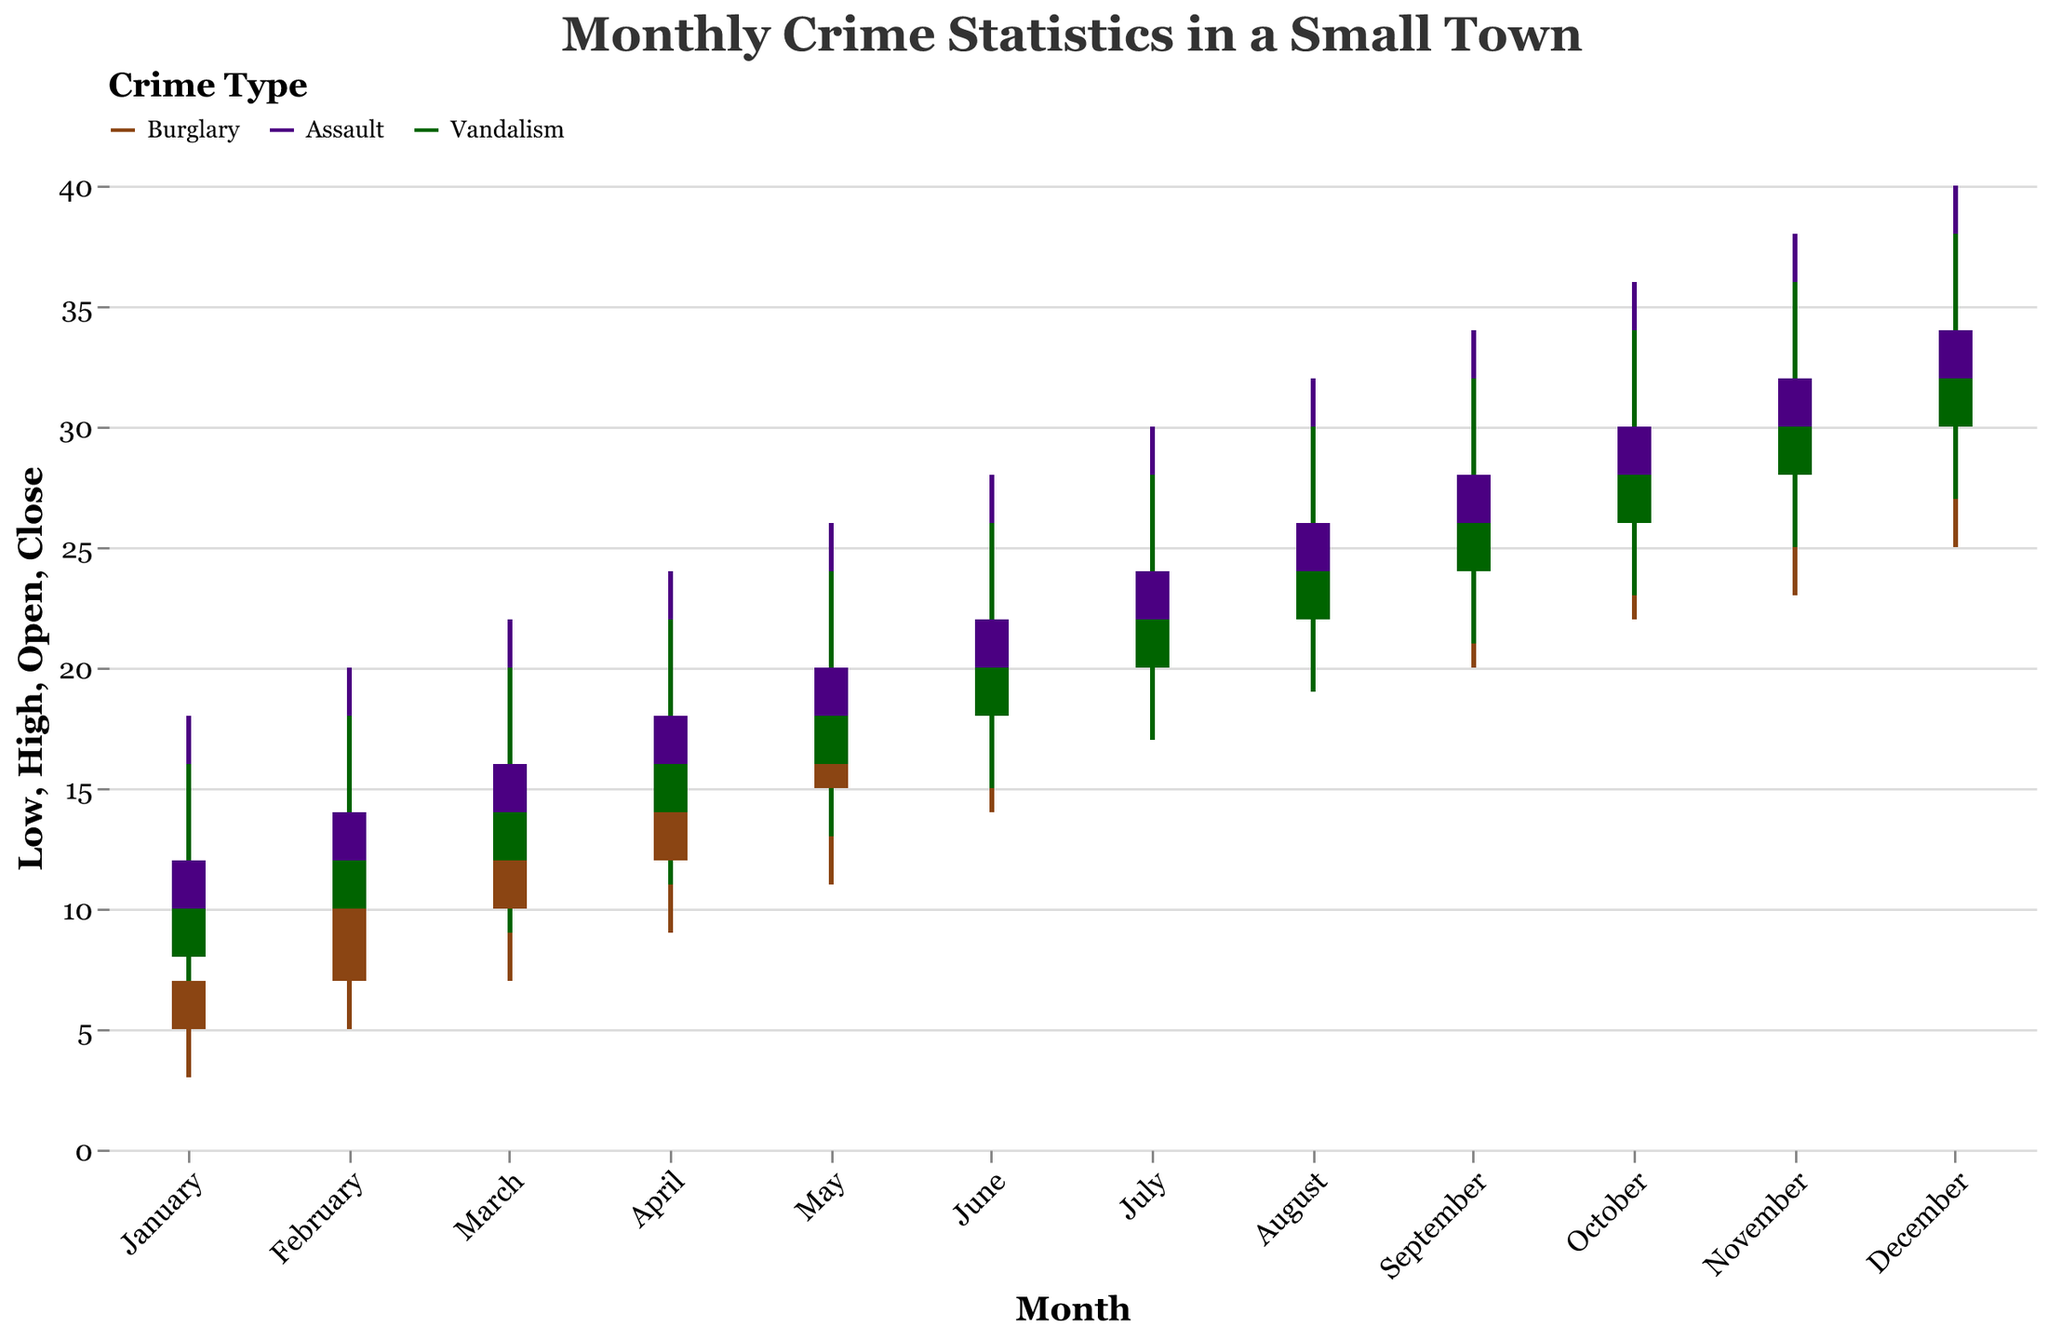What is the title of the candlestick chart? The title of the chart can be found at the top of the figure. It reads "Monthly Crime Statistics in a Small Town," which summarizes the content and focus of the visual representation.
Answer: Monthly Crime Statistics in a Small Town Which month recorded the highest number of burglary incidents? Referring to the candlestick bars for burglary, the number of incidents is highest in December. The "High" value of the candlestick for December is 36, which is the maximum among all months.
Answer: December What were the lowest and highest recorded values for assault in April? To find the lowest and highest values for assault in April, look at the candlestick for Assault in April. The "Low" value is 12 and the "High" value is 24.
Answer: 12 and 24 What is the difference between the opening and closing values for vandalism in August? For vandalism in August, the candlestick chart shows an "Open" value of 22 and a "Close" value of 24. The difference between these values is 24 - 22 = 2.
Answer: 2 How does the fluctuation range (difference between high and low values) for vandalism in September compare to that in October? The fluctuation range is calculated by subtracting the "Low" value from the "High" value. For September: 32 - 21 = 11. For October: 34 - 23 = 11. Both months have the same fluctuation range of 11.
Answer: The same Between which months does the number of assault incidents increase the most? To determine the largest increase, compare the "Close" values of each subsequent month for Assault. The largest increase is from November (Close=32) to December (Close=34), with an increase of 34 - 32 = 2 incidents.
Answer: November to December What color is used to represent burglary in the chart? The color legend at the top indicates the color associated with each crime type. Burglary is represented by a brown color on the chart.
Answer: Brown Which month shows an equal number of closing values for all three crime types? To find this, look for a month where the "Close" values align across all three crime types (Burglary, Assault, Vandalism). In July, all three crime types have their "Close" values at 22.
Answer: July What is the median closing value for burglary across the entire year? The closing values for burglary each month are: 7, 10, 12, 15, 18, 20, 22, 24, 26, 28, 30, and 32. Organize these values in ascending order and find the middle value(s). For even numbers of data points, average the two central values: (20 + 22) / 2 = 21.
Answer: 21 